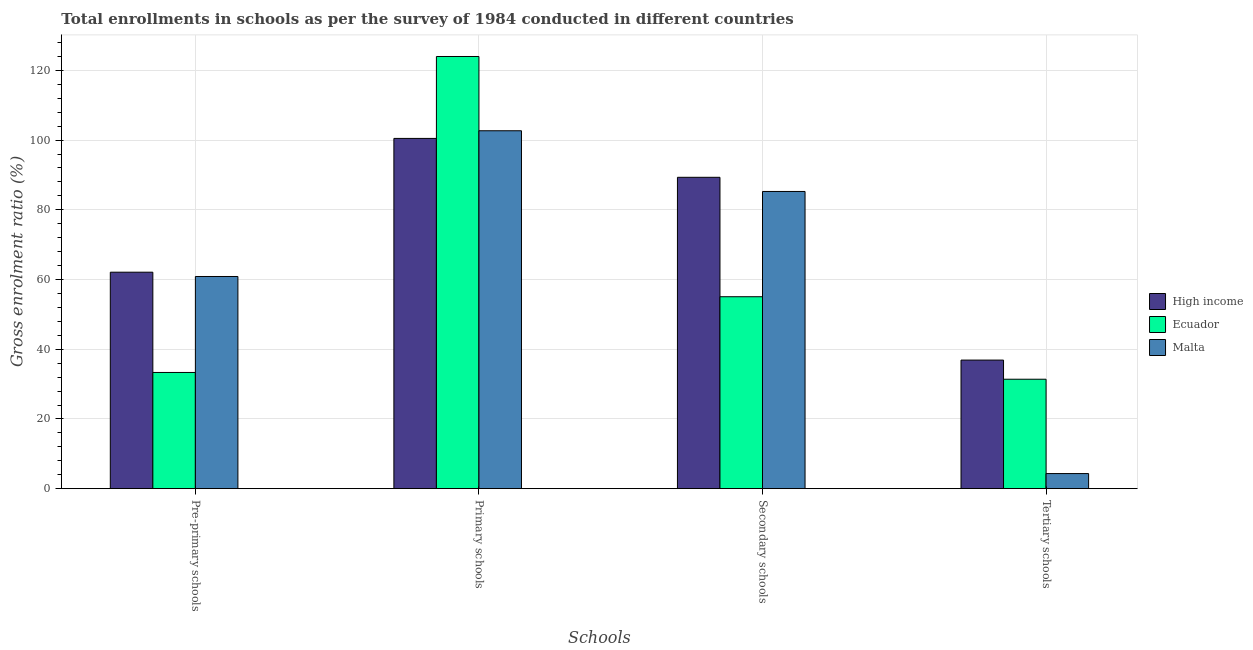How many different coloured bars are there?
Your answer should be very brief. 3. Are the number of bars on each tick of the X-axis equal?
Provide a short and direct response. Yes. How many bars are there on the 2nd tick from the left?
Your response must be concise. 3. How many bars are there on the 3rd tick from the right?
Keep it short and to the point. 3. What is the label of the 4th group of bars from the left?
Provide a succinct answer. Tertiary schools. What is the gross enrolment ratio in primary schools in Ecuador?
Offer a very short reply. 123.98. Across all countries, what is the maximum gross enrolment ratio in tertiary schools?
Provide a succinct answer. 36.89. Across all countries, what is the minimum gross enrolment ratio in primary schools?
Offer a very short reply. 100.48. In which country was the gross enrolment ratio in secondary schools minimum?
Your answer should be very brief. Ecuador. What is the total gross enrolment ratio in tertiary schools in the graph?
Ensure brevity in your answer.  72.62. What is the difference between the gross enrolment ratio in secondary schools in Ecuador and that in Malta?
Your response must be concise. -30.2. What is the difference between the gross enrolment ratio in pre-primary schools in High income and the gross enrolment ratio in tertiary schools in Ecuador?
Keep it short and to the point. 30.7. What is the average gross enrolment ratio in primary schools per country?
Your response must be concise. 109.04. What is the difference between the gross enrolment ratio in secondary schools and gross enrolment ratio in tertiary schools in Ecuador?
Ensure brevity in your answer.  23.67. What is the ratio of the gross enrolment ratio in primary schools in High income to that in Ecuador?
Your response must be concise. 0.81. What is the difference between the highest and the second highest gross enrolment ratio in primary schools?
Give a very brief answer. 21.31. What is the difference between the highest and the lowest gross enrolment ratio in primary schools?
Provide a succinct answer. 23.5. In how many countries, is the gross enrolment ratio in primary schools greater than the average gross enrolment ratio in primary schools taken over all countries?
Keep it short and to the point. 1. What does the 2nd bar from the left in Tertiary schools represents?
Keep it short and to the point. Ecuador. What does the 1st bar from the right in Pre-primary schools represents?
Give a very brief answer. Malta. Is it the case that in every country, the sum of the gross enrolment ratio in pre-primary schools and gross enrolment ratio in primary schools is greater than the gross enrolment ratio in secondary schools?
Keep it short and to the point. Yes. How many countries are there in the graph?
Your answer should be very brief. 3. What is the difference between two consecutive major ticks on the Y-axis?
Give a very brief answer. 20. Does the graph contain any zero values?
Your response must be concise. No. Does the graph contain grids?
Keep it short and to the point. Yes. What is the title of the graph?
Give a very brief answer. Total enrollments in schools as per the survey of 1984 conducted in different countries. What is the label or title of the X-axis?
Your answer should be very brief. Schools. What is the Gross enrolment ratio (%) in High income in Pre-primary schools?
Give a very brief answer. 62.1. What is the Gross enrolment ratio (%) of Ecuador in Pre-primary schools?
Ensure brevity in your answer.  33.34. What is the Gross enrolment ratio (%) of Malta in Pre-primary schools?
Your response must be concise. 60.87. What is the Gross enrolment ratio (%) of High income in Primary schools?
Keep it short and to the point. 100.48. What is the Gross enrolment ratio (%) in Ecuador in Primary schools?
Your response must be concise. 123.98. What is the Gross enrolment ratio (%) in Malta in Primary schools?
Keep it short and to the point. 102.67. What is the Gross enrolment ratio (%) in High income in Secondary schools?
Make the answer very short. 89.32. What is the Gross enrolment ratio (%) in Ecuador in Secondary schools?
Provide a short and direct response. 55.06. What is the Gross enrolment ratio (%) of Malta in Secondary schools?
Offer a terse response. 85.26. What is the Gross enrolment ratio (%) of High income in Tertiary schools?
Your answer should be compact. 36.89. What is the Gross enrolment ratio (%) in Ecuador in Tertiary schools?
Offer a very short reply. 31.4. What is the Gross enrolment ratio (%) of Malta in Tertiary schools?
Offer a terse response. 4.33. Across all Schools, what is the maximum Gross enrolment ratio (%) of High income?
Ensure brevity in your answer.  100.48. Across all Schools, what is the maximum Gross enrolment ratio (%) of Ecuador?
Ensure brevity in your answer.  123.98. Across all Schools, what is the maximum Gross enrolment ratio (%) of Malta?
Your response must be concise. 102.67. Across all Schools, what is the minimum Gross enrolment ratio (%) of High income?
Keep it short and to the point. 36.89. Across all Schools, what is the minimum Gross enrolment ratio (%) in Ecuador?
Make the answer very short. 31.4. Across all Schools, what is the minimum Gross enrolment ratio (%) in Malta?
Your answer should be very brief. 4.33. What is the total Gross enrolment ratio (%) in High income in the graph?
Make the answer very short. 288.78. What is the total Gross enrolment ratio (%) in Ecuador in the graph?
Offer a very short reply. 243.78. What is the total Gross enrolment ratio (%) in Malta in the graph?
Your response must be concise. 253.14. What is the difference between the Gross enrolment ratio (%) of High income in Pre-primary schools and that in Primary schools?
Ensure brevity in your answer.  -38.38. What is the difference between the Gross enrolment ratio (%) of Ecuador in Pre-primary schools and that in Primary schools?
Your answer should be compact. -90.64. What is the difference between the Gross enrolment ratio (%) of Malta in Pre-primary schools and that in Primary schools?
Your answer should be very brief. -41.81. What is the difference between the Gross enrolment ratio (%) of High income in Pre-primary schools and that in Secondary schools?
Provide a succinct answer. -27.22. What is the difference between the Gross enrolment ratio (%) in Ecuador in Pre-primary schools and that in Secondary schools?
Ensure brevity in your answer.  -21.72. What is the difference between the Gross enrolment ratio (%) in Malta in Pre-primary schools and that in Secondary schools?
Offer a terse response. -24.4. What is the difference between the Gross enrolment ratio (%) of High income in Pre-primary schools and that in Tertiary schools?
Make the answer very short. 25.21. What is the difference between the Gross enrolment ratio (%) in Ecuador in Pre-primary schools and that in Tertiary schools?
Make the answer very short. 1.94. What is the difference between the Gross enrolment ratio (%) of Malta in Pre-primary schools and that in Tertiary schools?
Your response must be concise. 56.53. What is the difference between the Gross enrolment ratio (%) of High income in Primary schools and that in Secondary schools?
Your answer should be very brief. 11.16. What is the difference between the Gross enrolment ratio (%) in Ecuador in Primary schools and that in Secondary schools?
Give a very brief answer. 68.92. What is the difference between the Gross enrolment ratio (%) in Malta in Primary schools and that in Secondary schools?
Provide a succinct answer. 17.41. What is the difference between the Gross enrolment ratio (%) of High income in Primary schools and that in Tertiary schools?
Keep it short and to the point. 63.59. What is the difference between the Gross enrolment ratio (%) in Ecuador in Primary schools and that in Tertiary schools?
Your answer should be very brief. 92.58. What is the difference between the Gross enrolment ratio (%) of Malta in Primary schools and that in Tertiary schools?
Your response must be concise. 98.34. What is the difference between the Gross enrolment ratio (%) of High income in Secondary schools and that in Tertiary schools?
Your response must be concise. 52.43. What is the difference between the Gross enrolment ratio (%) in Ecuador in Secondary schools and that in Tertiary schools?
Your response must be concise. 23.67. What is the difference between the Gross enrolment ratio (%) in Malta in Secondary schools and that in Tertiary schools?
Your answer should be compact. 80.93. What is the difference between the Gross enrolment ratio (%) in High income in Pre-primary schools and the Gross enrolment ratio (%) in Ecuador in Primary schools?
Offer a very short reply. -61.88. What is the difference between the Gross enrolment ratio (%) in High income in Pre-primary schools and the Gross enrolment ratio (%) in Malta in Primary schools?
Give a very brief answer. -40.57. What is the difference between the Gross enrolment ratio (%) of Ecuador in Pre-primary schools and the Gross enrolment ratio (%) of Malta in Primary schools?
Give a very brief answer. -69.33. What is the difference between the Gross enrolment ratio (%) of High income in Pre-primary schools and the Gross enrolment ratio (%) of Ecuador in Secondary schools?
Your answer should be compact. 7.04. What is the difference between the Gross enrolment ratio (%) of High income in Pre-primary schools and the Gross enrolment ratio (%) of Malta in Secondary schools?
Give a very brief answer. -23.16. What is the difference between the Gross enrolment ratio (%) in Ecuador in Pre-primary schools and the Gross enrolment ratio (%) in Malta in Secondary schools?
Keep it short and to the point. -51.92. What is the difference between the Gross enrolment ratio (%) of High income in Pre-primary schools and the Gross enrolment ratio (%) of Ecuador in Tertiary schools?
Your answer should be very brief. 30.7. What is the difference between the Gross enrolment ratio (%) of High income in Pre-primary schools and the Gross enrolment ratio (%) of Malta in Tertiary schools?
Offer a very short reply. 57.76. What is the difference between the Gross enrolment ratio (%) in Ecuador in Pre-primary schools and the Gross enrolment ratio (%) in Malta in Tertiary schools?
Provide a succinct answer. 29. What is the difference between the Gross enrolment ratio (%) in High income in Primary schools and the Gross enrolment ratio (%) in Ecuador in Secondary schools?
Your response must be concise. 45.41. What is the difference between the Gross enrolment ratio (%) of High income in Primary schools and the Gross enrolment ratio (%) of Malta in Secondary schools?
Offer a terse response. 15.21. What is the difference between the Gross enrolment ratio (%) of Ecuador in Primary schools and the Gross enrolment ratio (%) of Malta in Secondary schools?
Give a very brief answer. 38.72. What is the difference between the Gross enrolment ratio (%) of High income in Primary schools and the Gross enrolment ratio (%) of Ecuador in Tertiary schools?
Provide a succinct answer. 69.08. What is the difference between the Gross enrolment ratio (%) of High income in Primary schools and the Gross enrolment ratio (%) of Malta in Tertiary schools?
Keep it short and to the point. 96.14. What is the difference between the Gross enrolment ratio (%) of Ecuador in Primary schools and the Gross enrolment ratio (%) of Malta in Tertiary schools?
Keep it short and to the point. 119.64. What is the difference between the Gross enrolment ratio (%) in High income in Secondary schools and the Gross enrolment ratio (%) in Ecuador in Tertiary schools?
Your answer should be compact. 57.92. What is the difference between the Gross enrolment ratio (%) in High income in Secondary schools and the Gross enrolment ratio (%) in Malta in Tertiary schools?
Make the answer very short. 84.98. What is the difference between the Gross enrolment ratio (%) in Ecuador in Secondary schools and the Gross enrolment ratio (%) in Malta in Tertiary schools?
Your response must be concise. 50.73. What is the average Gross enrolment ratio (%) in High income per Schools?
Keep it short and to the point. 72.2. What is the average Gross enrolment ratio (%) in Ecuador per Schools?
Keep it short and to the point. 60.94. What is the average Gross enrolment ratio (%) of Malta per Schools?
Keep it short and to the point. 63.28. What is the difference between the Gross enrolment ratio (%) in High income and Gross enrolment ratio (%) in Ecuador in Pre-primary schools?
Provide a succinct answer. 28.76. What is the difference between the Gross enrolment ratio (%) in High income and Gross enrolment ratio (%) in Malta in Pre-primary schools?
Your response must be concise. 1.23. What is the difference between the Gross enrolment ratio (%) of Ecuador and Gross enrolment ratio (%) of Malta in Pre-primary schools?
Keep it short and to the point. -27.53. What is the difference between the Gross enrolment ratio (%) of High income and Gross enrolment ratio (%) of Ecuador in Primary schools?
Your answer should be very brief. -23.5. What is the difference between the Gross enrolment ratio (%) in High income and Gross enrolment ratio (%) in Malta in Primary schools?
Provide a short and direct response. -2.2. What is the difference between the Gross enrolment ratio (%) in Ecuador and Gross enrolment ratio (%) in Malta in Primary schools?
Offer a terse response. 21.31. What is the difference between the Gross enrolment ratio (%) of High income and Gross enrolment ratio (%) of Ecuador in Secondary schools?
Offer a very short reply. 34.26. What is the difference between the Gross enrolment ratio (%) in High income and Gross enrolment ratio (%) in Malta in Secondary schools?
Your answer should be compact. 4.06. What is the difference between the Gross enrolment ratio (%) in Ecuador and Gross enrolment ratio (%) in Malta in Secondary schools?
Provide a short and direct response. -30.2. What is the difference between the Gross enrolment ratio (%) in High income and Gross enrolment ratio (%) in Ecuador in Tertiary schools?
Offer a terse response. 5.49. What is the difference between the Gross enrolment ratio (%) of High income and Gross enrolment ratio (%) of Malta in Tertiary schools?
Your response must be concise. 32.55. What is the difference between the Gross enrolment ratio (%) of Ecuador and Gross enrolment ratio (%) of Malta in Tertiary schools?
Offer a very short reply. 27.06. What is the ratio of the Gross enrolment ratio (%) of High income in Pre-primary schools to that in Primary schools?
Your response must be concise. 0.62. What is the ratio of the Gross enrolment ratio (%) of Ecuador in Pre-primary schools to that in Primary schools?
Your answer should be very brief. 0.27. What is the ratio of the Gross enrolment ratio (%) of Malta in Pre-primary schools to that in Primary schools?
Your answer should be compact. 0.59. What is the ratio of the Gross enrolment ratio (%) of High income in Pre-primary schools to that in Secondary schools?
Your response must be concise. 0.7. What is the ratio of the Gross enrolment ratio (%) of Ecuador in Pre-primary schools to that in Secondary schools?
Your response must be concise. 0.61. What is the ratio of the Gross enrolment ratio (%) in Malta in Pre-primary schools to that in Secondary schools?
Your response must be concise. 0.71. What is the ratio of the Gross enrolment ratio (%) in High income in Pre-primary schools to that in Tertiary schools?
Offer a terse response. 1.68. What is the ratio of the Gross enrolment ratio (%) in Ecuador in Pre-primary schools to that in Tertiary schools?
Your response must be concise. 1.06. What is the ratio of the Gross enrolment ratio (%) of Malta in Pre-primary schools to that in Tertiary schools?
Give a very brief answer. 14.04. What is the ratio of the Gross enrolment ratio (%) of High income in Primary schools to that in Secondary schools?
Provide a short and direct response. 1.12. What is the ratio of the Gross enrolment ratio (%) in Ecuador in Primary schools to that in Secondary schools?
Give a very brief answer. 2.25. What is the ratio of the Gross enrolment ratio (%) of Malta in Primary schools to that in Secondary schools?
Give a very brief answer. 1.2. What is the ratio of the Gross enrolment ratio (%) in High income in Primary schools to that in Tertiary schools?
Keep it short and to the point. 2.72. What is the ratio of the Gross enrolment ratio (%) in Ecuador in Primary schools to that in Tertiary schools?
Give a very brief answer. 3.95. What is the ratio of the Gross enrolment ratio (%) of Malta in Primary schools to that in Tertiary schools?
Offer a terse response. 23.68. What is the ratio of the Gross enrolment ratio (%) of High income in Secondary schools to that in Tertiary schools?
Provide a succinct answer. 2.42. What is the ratio of the Gross enrolment ratio (%) in Ecuador in Secondary schools to that in Tertiary schools?
Provide a succinct answer. 1.75. What is the ratio of the Gross enrolment ratio (%) of Malta in Secondary schools to that in Tertiary schools?
Provide a succinct answer. 19.67. What is the difference between the highest and the second highest Gross enrolment ratio (%) in High income?
Your answer should be very brief. 11.16. What is the difference between the highest and the second highest Gross enrolment ratio (%) of Ecuador?
Provide a short and direct response. 68.92. What is the difference between the highest and the second highest Gross enrolment ratio (%) of Malta?
Your response must be concise. 17.41. What is the difference between the highest and the lowest Gross enrolment ratio (%) of High income?
Offer a very short reply. 63.59. What is the difference between the highest and the lowest Gross enrolment ratio (%) in Ecuador?
Your answer should be compact. 92.58. What is the difference between the highest and the lowest Gross enrolment ratio (%) of Malta?
Ensure brevity in your answer.  98.34. 